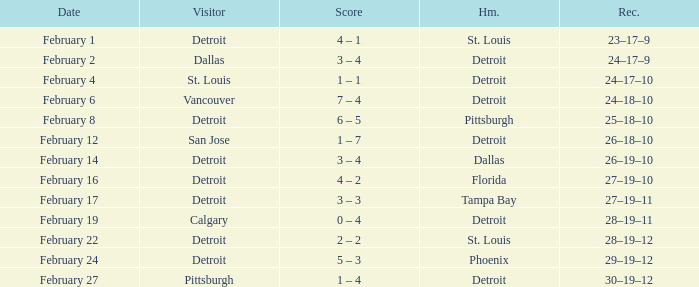Write the full table. {'header': ['Date', 'Visitor', 'Score', 'Hm.', 'Rec.'], 'rows': [['February 1', 'Detroit', '4 – 1', 'St. Louis', '23–17–9'], ['February 2', 'Dallas', '3 – 4', 'Detroit', '24–17–9'], ['February 4', 'St. Louis', '1 – 1', 'Detroit', '24–17–10'], ['February 6', 'Vancouver', '7 – 4', 'Detroit', '24–18–10'], ['February 8', 'Detroit', '6 – 5', 'Pittsburgh', '25–18–10'], ['February 12', 'San Jose', '1 – 7', 'Detroit', '26–18–10'], ['February 14', 'Detroit', '3 – 4', 'Dallas', '26–19–10'], ['February 16', 'Detroit', '4 – 2', 'Florida', '27–19–10'], ['February 17', 'Detroit', '3 – 3', 'Tampa Bay', '27–19–11'], ['February 19', 'Calgary', '0 – 4', 'Detroit', '28–19–11'], ['February 22', 'Detroit', '2 – 2', 'St. Louis', '28–19–12'], ['February 24', 'Detroit', '5 – 3', 'Phoenix', '29–19–12'], ['February 27', 'Pittsburgh', '1 – 4', 'Detroit', '30–19–12']]} What was their record when they were at Pittsburgh? 25–18–10. 